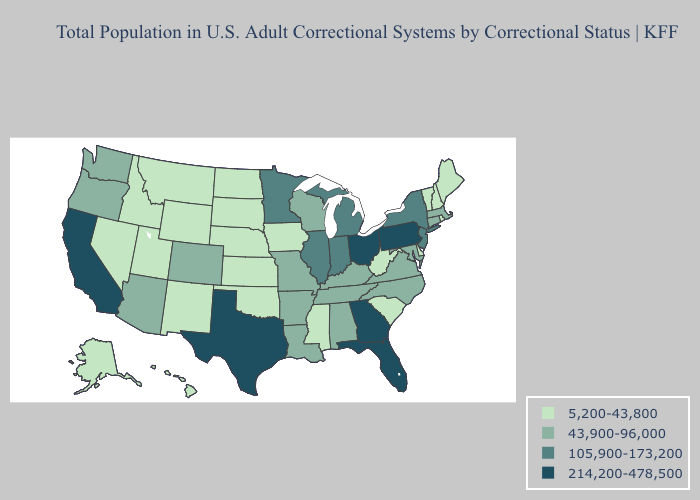What is the value of Hawaii?
Concise answer only. 5,200-43,800. Does New Jersey have the lowest value in the Northeast?
Keep it brief. No. Does Texas have the highest value in the South?
Short answer required. Yes. How many symbols are there in the legend?
Short answer required. 4. What is the value of Pennsylvania?
Concise answer only. 214,200-478,500. Among the states that border New Jersey , which have the highest value?
Give a very brief answer. Pennsylvania. Name the states that have a value in the range 105,900-173,200?
Give a very brief answer. Illinois, Indiana, Michigan, Minnesota, New Jersey, New York. Name the states that have a value in the range 5,200-43,800?
Quick response, please. Alaska, Delaware, Hawaii, Idaho, Iowa, Kansas, Maine, Mississippi, Montana, Nebraska, Nevada, New Hampshire, New Mexico, North Dakota, Oklahoma, Rhode Island, South Carolina, South Dakota, Utah, Vermont, West Virginia, Wyoming. Does Maryland have the same value as Kentucky?
Give a very brief answer. Yes. Which states have the lowest value in the USA?
Concise answer only. Alaska, Delaware, Hawaii, Idaho, Iowa, Kansas, Maine, Mississippi, Montana, Nebraska, Nevada, New Hampshire, New Mexico, North Dakota, Oklahoma, Rhode Island, South Carolina, South Dakota, Utah, Vermont, West Virginia, Wyoming. What is the highest value in the USA?
Be succinct. 214,200-478,500. Which states have the highest value in the USA?
Be succinct. California, Florida, Georgia, Ohio, Pennsylvania, Texas. Among the states that border Missouri , which have the highest value?
Short answer required. Illinois. Which states have the lowest value in the USA?
Be succinct. Alaska, Delaware, Hawaii, Idaho, Iowa, Kansas, Maine, Mississippi, Montana, Nebraska, Nevada, New Hampshire, New Mexico, North Dakota, Oklahoma, Rhode Island, South Carolina, South Dakota, Utah, Vermont, West Virginia, Wyoming. Does Delaware have the lowest value in the South?
Keep it brief. Yes. 